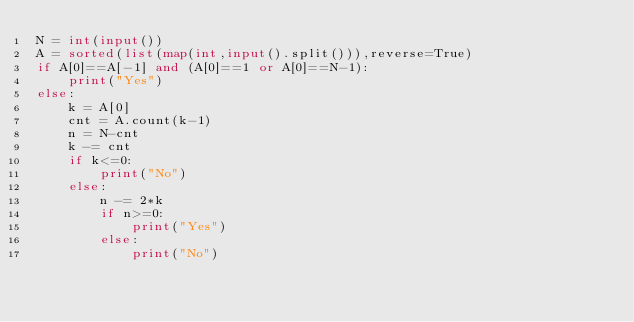Convert code to text. <code><loc_0><loc_0><loc_500><loc_500><_Python_>N = int(input())
A = sorted(list(map(int,input().split())),reverse=True)
if A[0]==A[-1] and (A[0]==1 or A[0]==N-1):
    print("Yes")
else:
    k = A[0]
    cnt = A.count(k-1)
    n = N-cnt
    k -= cnt
    if k<=0:
        print("No")
    else:
        n -= 2*k
        if n>=0:
            print("Yes")
        else:
            print("No")</code> 